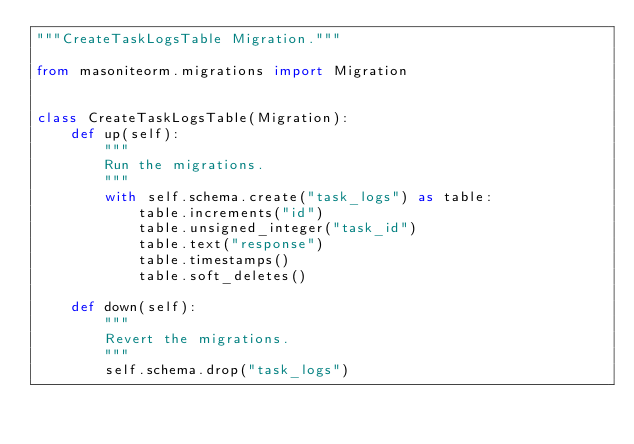Convert code to text. <code><loc_0><loc_0><loc_500><loc_500><_Python_>"""CreateTaskLogsTable Migration."""

from masoniteorm.migrations import Migration


class CreateTaskLogsTable(Migration):
    def up(self):
        """
        Run the migrations.
        """
        with self.schema.create("task_logs") as table:
            table.increments("id")
            table.unsigned_integer("task_id")
            table.text("response")
            table.timestamps()
            table.soft_deletes()

    def down(self):
        """
        Revert the migrations.
        """
        self.schema.drop("task_logs")
</code> 